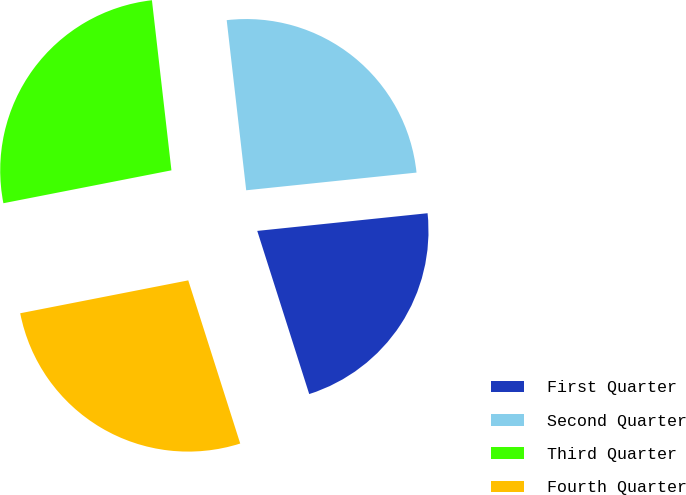Convert chart. <chart><loc_0><loc_0><loc_500><loc_500><pie_chart><fcel>First Quarter<fcel>Second Quarter<fcel>Third Quarter<fcel>Fourth Quarter<nl><fcel>21.74%<fcel>25.17%<fcel>26.26%<fcel>26.83%<nl></chart> 